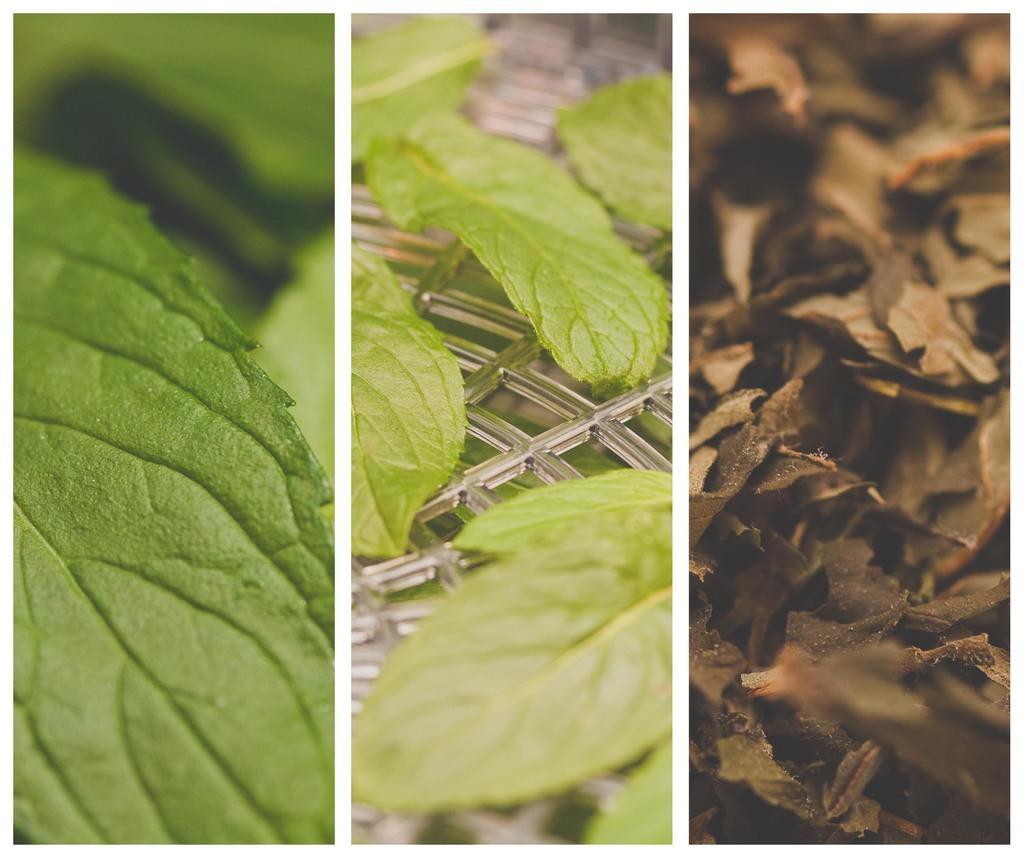Please provide a concise description of this image. It is a collage image, there are three different images of leaves. 